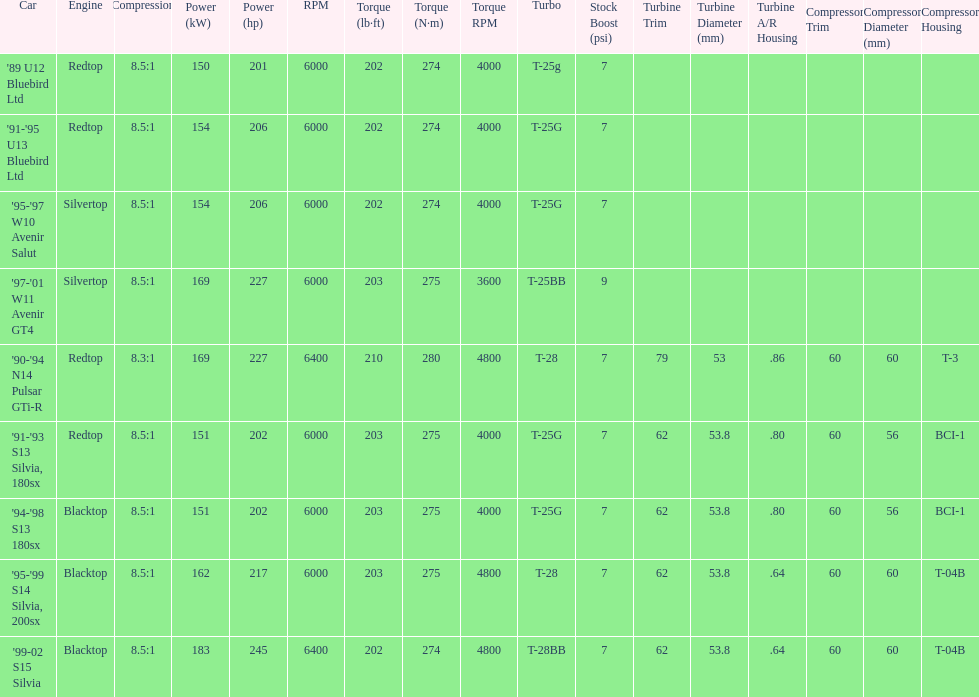Which car's power measured at higher than 6000 rpm? '90-'94 N14 Pulsar GTi-R, '99-02 S15 Silvia. 